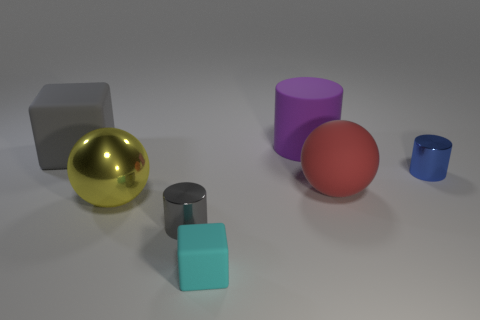Is there anything else that is the same color as the rubber sphere?
Your answer should be compact. No. There is a red rubber object that is in front of the metal cylinder that is on the right side of the big red matte object; is there a big thing that is to the right of it?
Your response must be concise. No. There is a big matte object that is in front of the big gray block; is its color the same as the tiny matte object?
Your answer should be compact. No. How many cylinders are either small shiny things or tiny blue metal things?
Provide a succinct answer. 2. The gray object that is to the left of the gray object to the right of the gray cube is what shape?
Offer a terse response. Cube. There is a cube right of the block left of the cylinder that is to the left of the big purple cylinder; what size is it?
Your answer should be compact. Small. Is the blue shiny object the same size as the purple rubber cylinder?
Keep it short and to the point. No. What number of objects are either gray metallic cylinders or big cyan rubber blocks?
Offer a terse response. 1. How big is the gray thing behind the gray thing in front of the big rubber sphere?
Make the answer very short. Large. What is the size of the blue thing?
Your response must be concise. Small. 